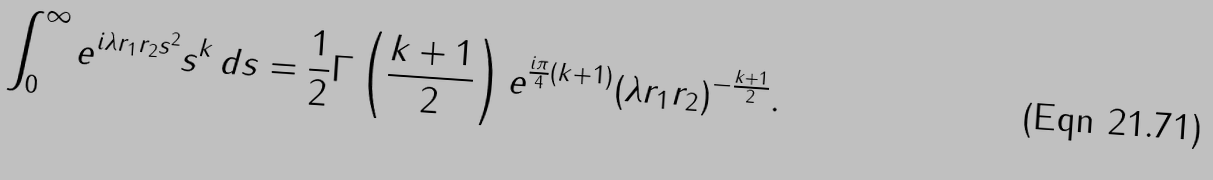Convert formula to latex. <formula><loc_0><loc_0><loc_500><loc_500>\int _ { 0 } ^ { \infty } e ^ { i \lambda r _ { 1 } r _ { 2 } s ^ { 2 } } s ^ { k } \, d s = \frac { 1 } { 2 } \Gamma \left ( \frac { k + 1 } { 2 } \right ) e ^ { \frac { i \pi } { 4 } ( k + 1 ) } ( \lambda r _ { 1 } r _ { 2 } ) ^ { - \frac { k + 1 } { 2 } } .</formula> 